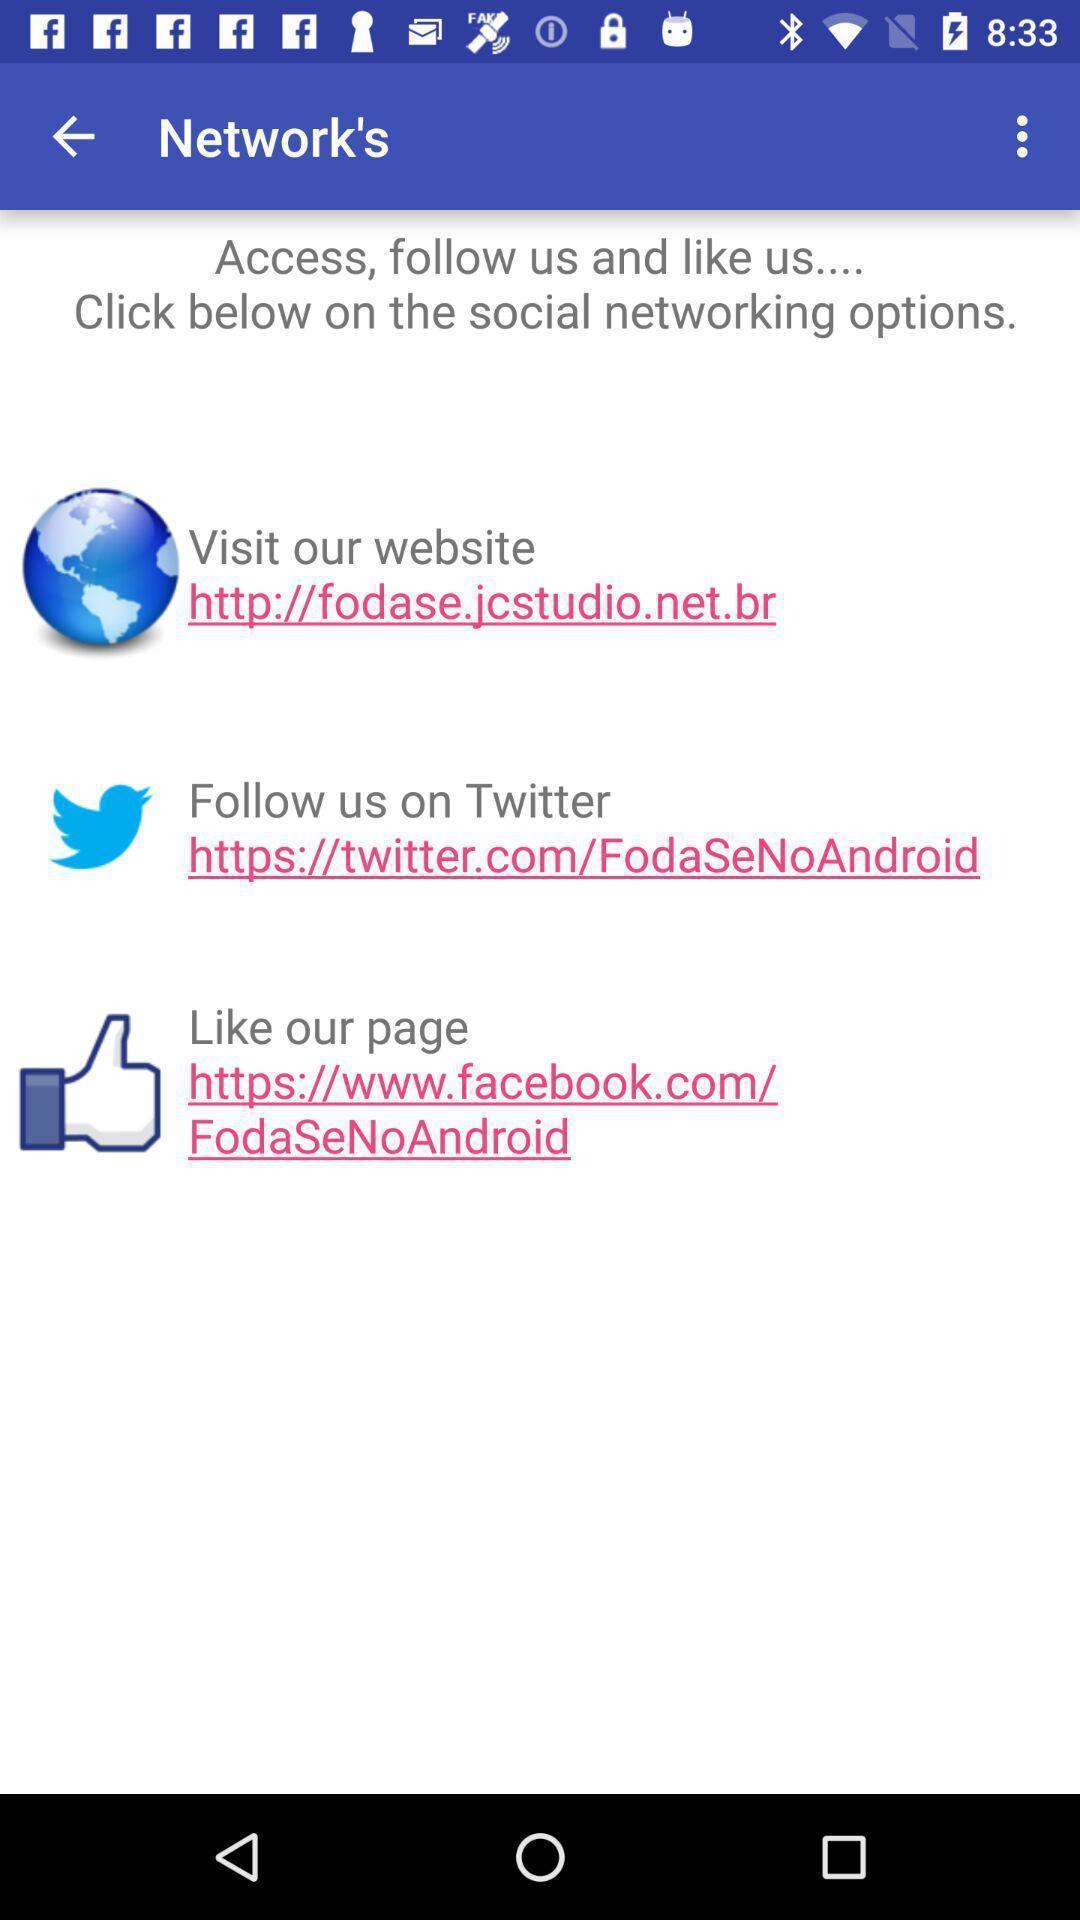Summarize the information in this screenshot. Page with different links of social networking option. 